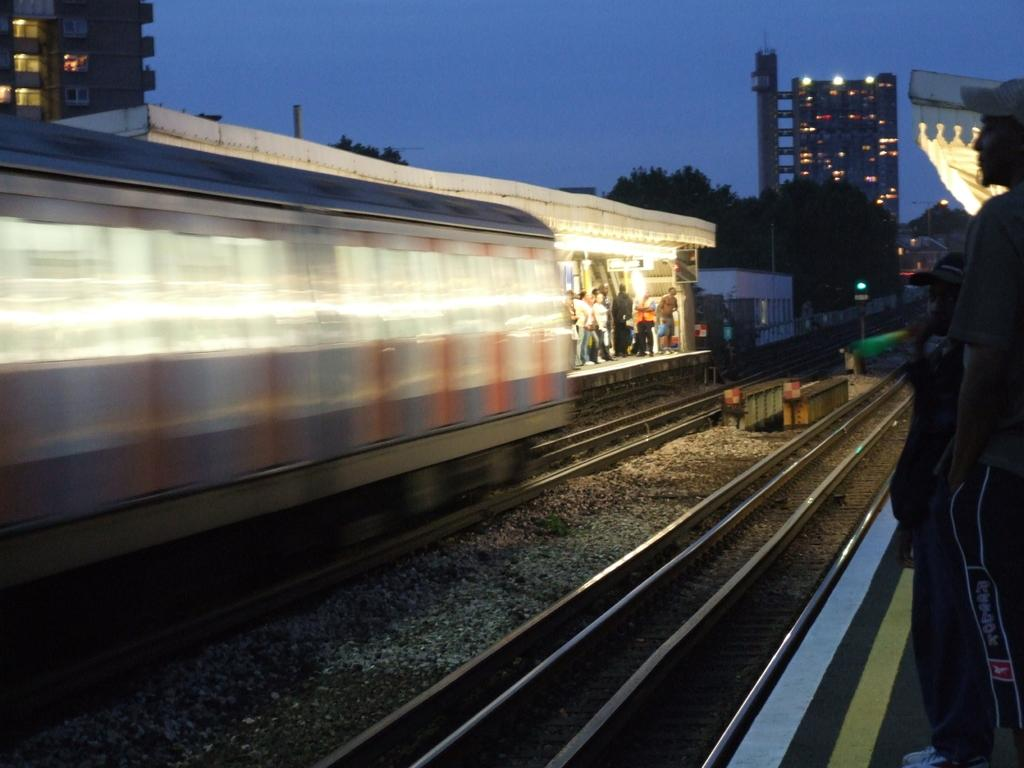What is the main subject in the center of the image? There is a train in the center of the image. What is the train traveling on? The train is traveling on railway tracks. What can be seen in the background of the image? The sky, trees, buildings, lights, poles, and people are visible in the background of the image. What type of cheese is being served at the committee meeting in the image? There is no committee meeting or cheese present in the image; it features a train and its surroundings. Can you tell me how many people are swimming in the ocean in the image? There is no ocean or people swimming in the image; it features a train and its surroundings. 